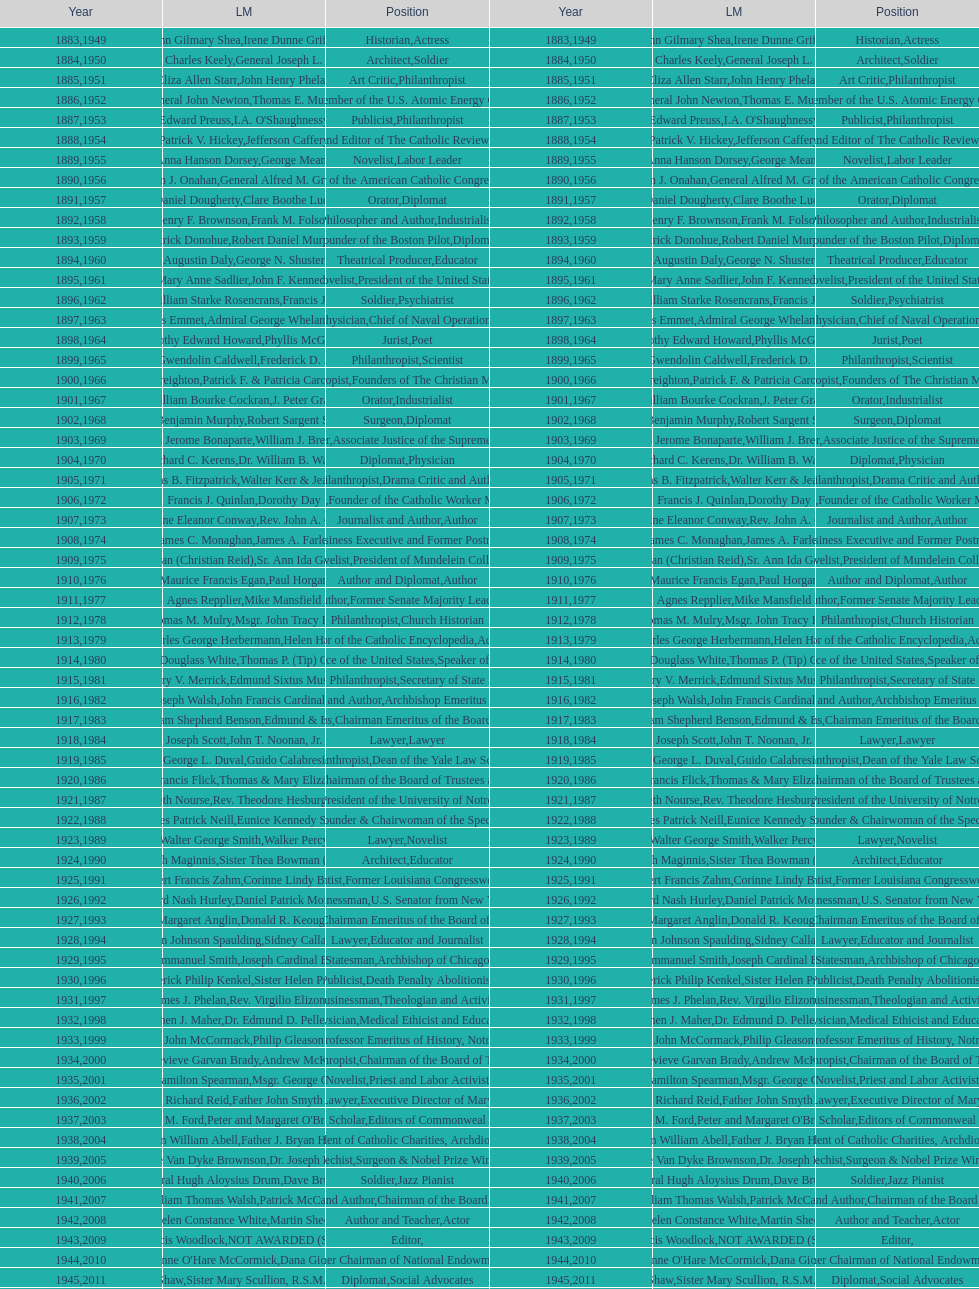How many laetare medal awardees have held a position as a diplomat? 8. 